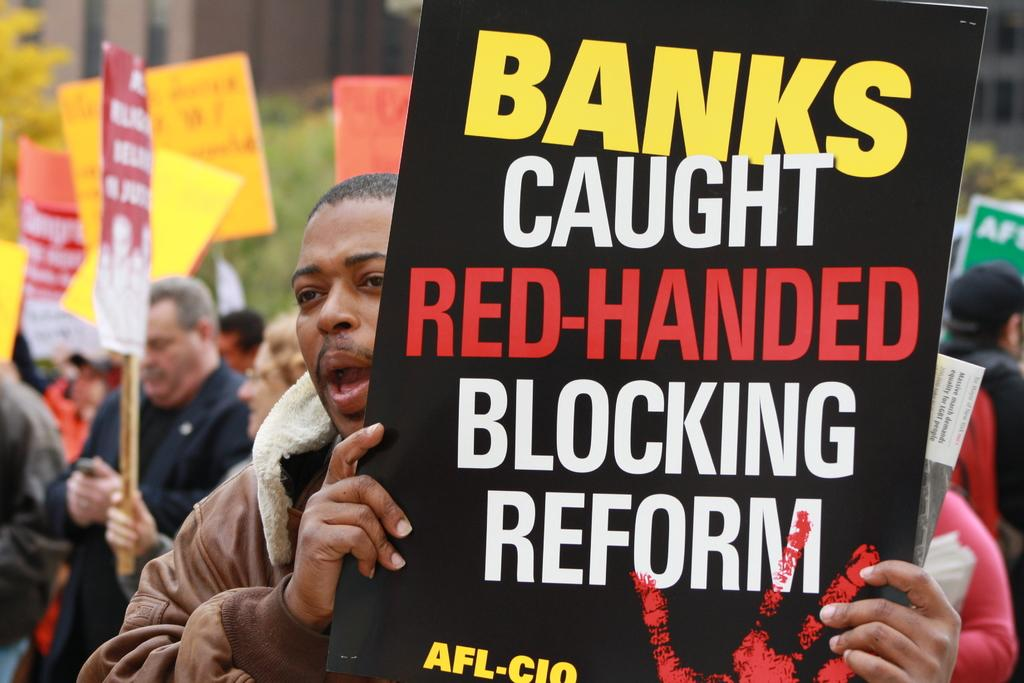How many people are in the image? There is a group of people in the image. What are the people doing in the image? The people are standing in the image. What are the people holding in their hands? The people are holding placards in their hands. What can be seen on the placards? There is writing on the placards. How many frogs can be seen jumping in the image? There are no frogs present in the image. What type of current is flowing through the image? There is no current present in the image. 